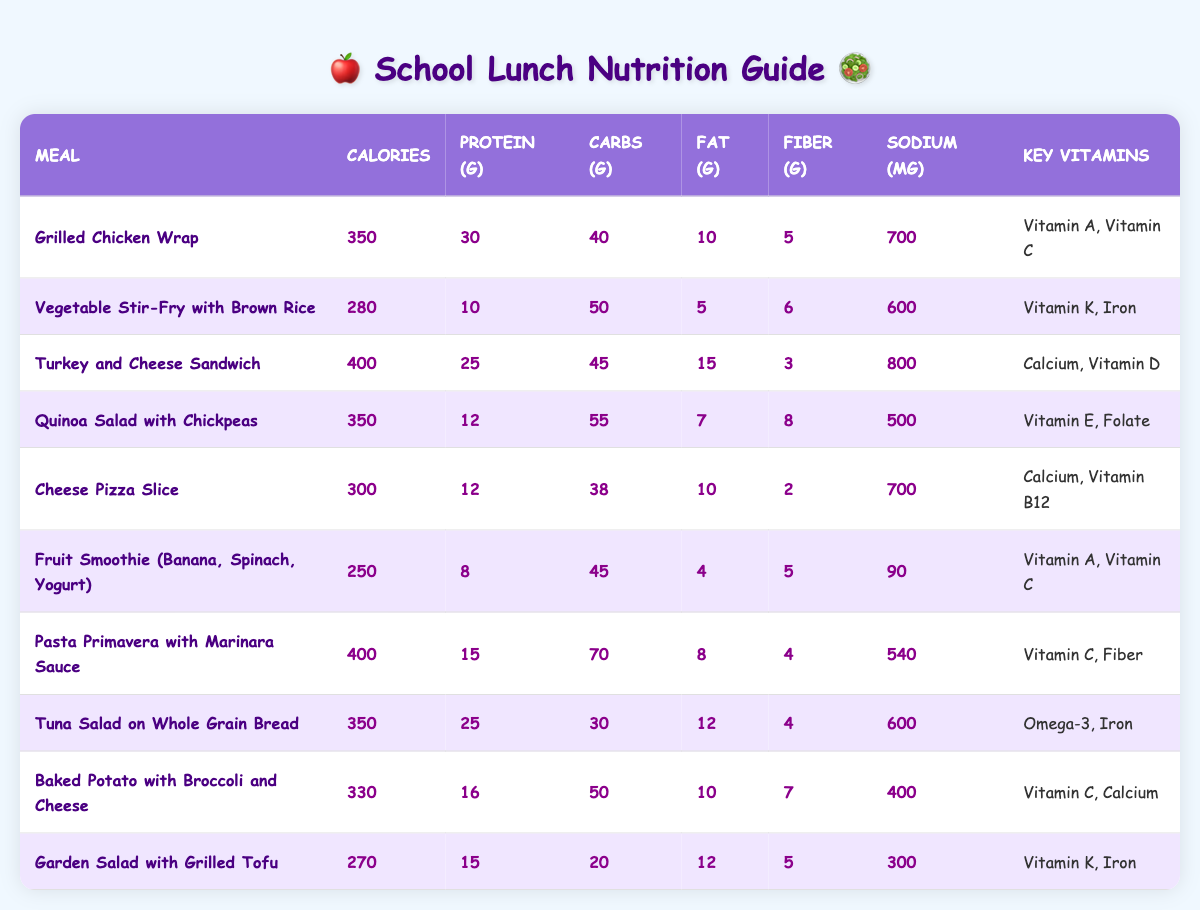What meal has the highest calories? Looking through the table, the meal with the highest calorie count is "Turkey and Cheese Sandwich," which has 400 calories.
Answer: Turkey and Cheese Sandwich Which meal contains the most protein? From the table, "Grilled Chicken Wrap" has 30 grams of protein, making it the meal with the highest protein content.
Answer: Grilled Chicken Wrap What is the lowest amount of sodium in any meal? The meal with the lowest sodium content is the "Fruit Smoothie," which has only 90 mg of sodium.
Answer: 90 mg How many meals have more than 300 calories? Counting the meals with more than 300 calories: "Grilled Chicken Wrap," "Turkey and Cheese Sandwich," "Quinoa Salad with Chickpeas," "Cheese Pizza Slice," "Pasta Primavera with Marinara Sauce," "Tuna Salad on Whole Grain Bread," "Baked Potato with Broccoli and Cheese," and "Turkey and Cheese Sandwich." That’s a total of 8 meals.
Answer: 8 meals What is the average fat content of all meals? Adding up the fat content: 10 + 5 + 15 + 7 + 10 + 4 + 8 + 12 + 10 + 12 = 93. There are 10 meals, so dividing 93 by 10 gives an average fat content of 9.3 grams.
Answer: 9.3 grams Which meal has the least amount of fiber? The meal with the least amount of fiber is "Cheese Pizza Slice," which contains only 2 grams of fiber.
Answer: 2 grams Are there any meals that contain both Vitamin A and Vitamin C? Yes, the "Grilled Chicken Wrap" and "Fruit Smoothie" both contain Vitamin A and C.
Answer: Yes What percentage of meals contain more than 500 mg of sodium? There are 10 meals overall. The following meals have more than 500 mg of sodium: "Grilled Chicken Wrap," "Turkey and Cheese Sandwich," "Tuna Salad on Whole Grain Bread," and "Cheese Pizza Slice." That's 4 out of 10 meals. Thus, the percentage is (4/10)*100 = 40%.
Answer: 40% How many meals have fewer than 300 calories and more than 10 grams of fat? Only "Fruit Smoothie" meets the criteria of fewer than 300 calories (250 calories) and greater than 10 grams of fat (4 grams). Therefore, the answer is 0.
Answer: 0 meals Which meal is the most nutritious in terms of fiber, protein, and vitamins combined? The "Quinoa Salad with Chickpeas" has 12 grams of protein, 8 grams of fiber, and contains Vitamin E and Folate, making it the most nutritious choice when combining these factors.
Answer: Quinoa Salad with Chickpeas 